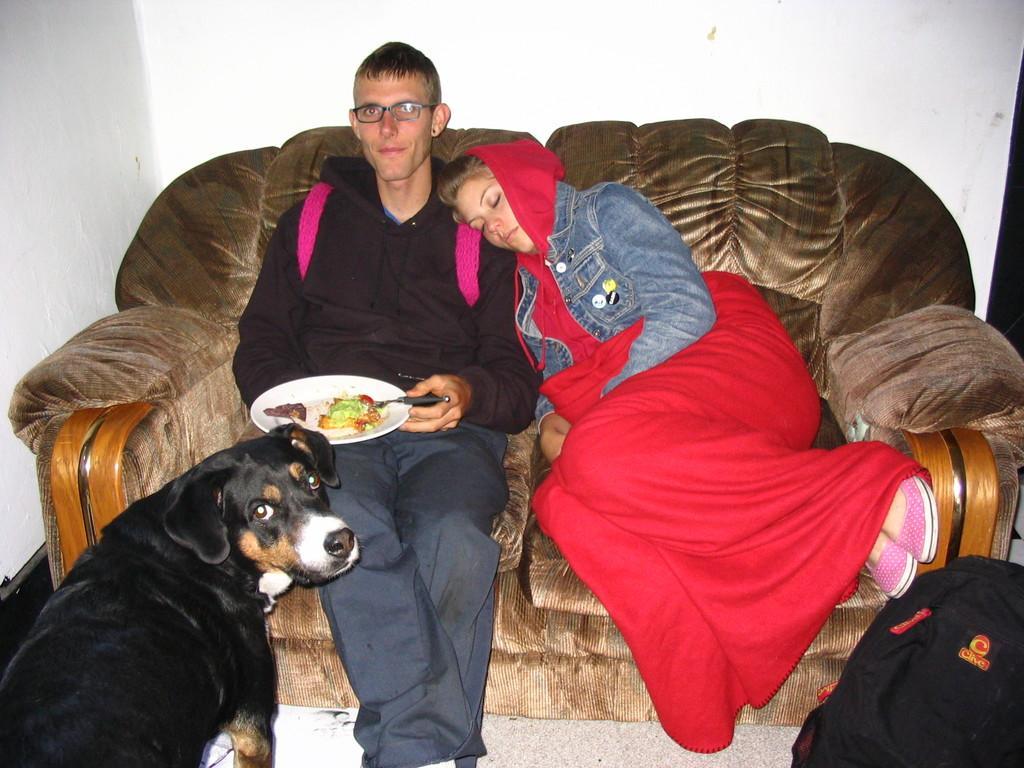Can you describe this image briefly? In this picture we can see a man and woman, they are sitting on the sofa and he is holding a plate, in front of him we can see a dog and a bag, we can see food in the plate. 